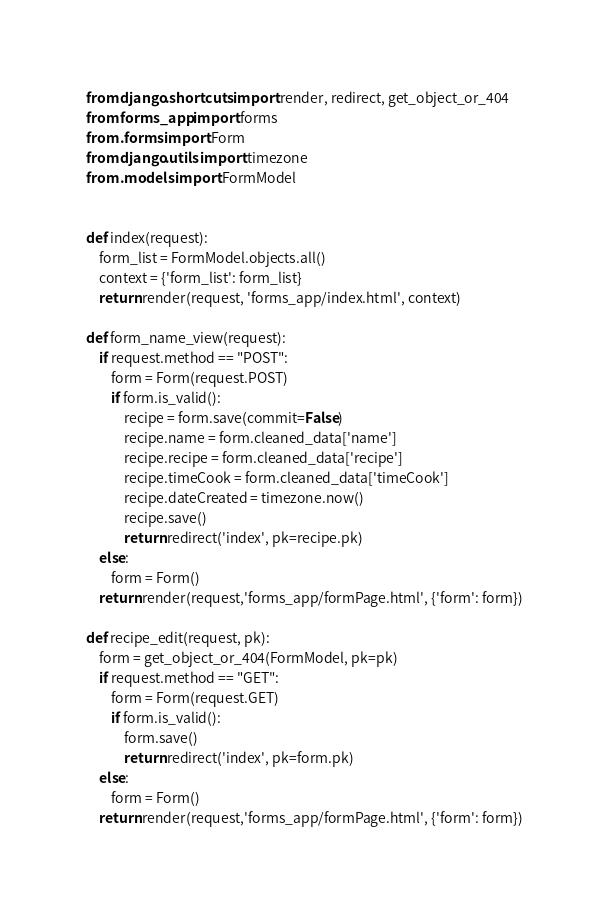<code> <loc_0><loc_0><loc_500><loc_500><_Python_>from django.shortcuts import render, redirect, get_object_or_404
from forms_app import forms
from .forms import Form
from django.utils import timezone
from .models import FormModel


def index(request):
    form_list = FormModel.objects.all()
    context = {'form_list': form_list}
    return render(request, 'forms_app/index.html', context)

def form_name_view(request):
    if request.method == "POST":
        form = Form(request.POST)
        if form.is_valid():
            recipe = form.save(commit=False)
            recipe.name = form.cleaned_data['name']
            recipe.recipe = form.cleaned_data['recipe']
            recipe.timeCook = form.cleaned_data['timeCook']
            recipe.dateCreated = timezone.now()
            recipe.save()
            return redirect('index', pk=recipe.pk)
    else:
        form = Form()
    return render(request,'forms_app/formPage.html', {'form': form})

def recipe_edit(request, pk):
    form = get_object_or_404(FormModel, pk=pk)
    if request.method == "GET":
        form = Form(request.GET)
        if form.is_valid():
            form.save()
            return redirect('index', pk=form.pk)
    else:
        form = Form()
    return render(request,'forms_app/formPage.html', {'form': form})

</code> 